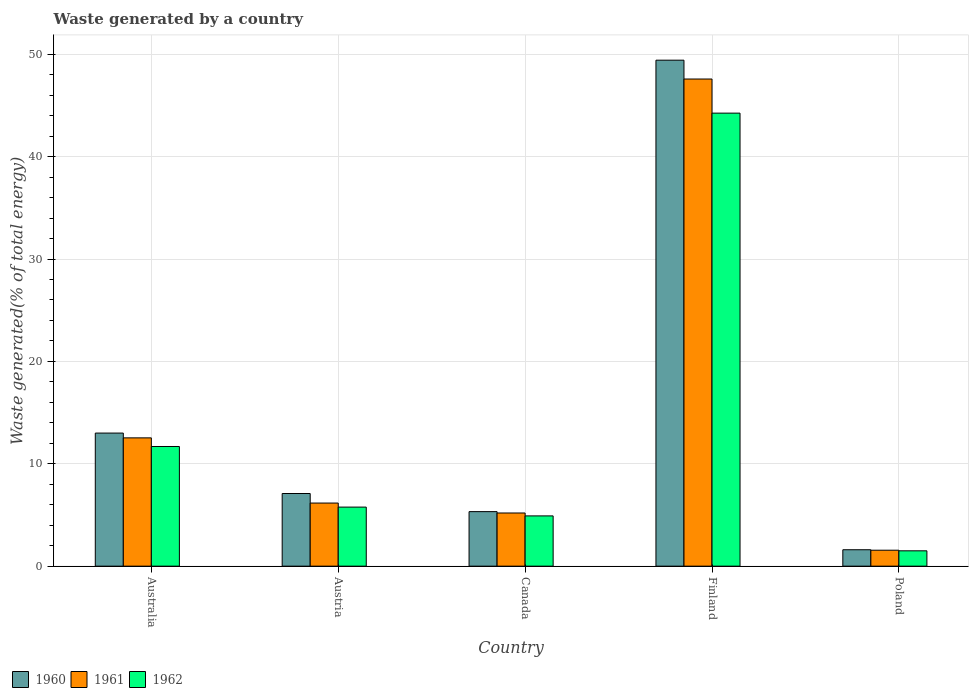How many different coloured bars are there?
Your response must be concise. 3. How many groups of bars are there?
Make the answer very short. 5. Are the number of bars per tick equal to the number of legend labels?
Provide a short and direct response. Yes. What is the label of the 3rd group of bars from the left?
Give a very brief answer. Canada. What is the total waste generated in 1961 in Australia?
Ensure brevity in your answer.  12.53. Across all countries, what is the maximum total waste generated in 1961?
Give a very brief answer. 47.58. Across all countries, what is the minimum total waste generated in 1962?
Offer a terse response. 1.5. What is the total total waste generated in 1962 in the graph?
Make the answer very short. 68.12. What is the difference between the total waste generated in 1960 in Austria and that in Poland?
Provide a succinct answer. 5.49. What is the difference between the total waste generated in 1962 in Poland and the total waste generated in 1961 in Canada?
Give a very brief answer. -3.7. What is the average total waste generated in 1962 per country?
Keep it short and to the point. 13.62. What is the difference between the total waste generated of/in 1962 and total waste generated of/in 1961 in Austria?
Keep it short and to the point. -0.4. In how many countries, is the total waste generated in 1962 greater than 12 %?
Keep it short and to the point. 1. What is the ratio of the total waste generated in 1962 in Australia to that in Poland?
Ensure brevity in your answer.  7.8. Is the total waste generated in 1961 in Canada less than that in Finland?
Make the answer very short. Yes. Is the difference between the total waste generated in 1962 in Austria and Canada greater than the difference between the total waste generated in 1961 in Austria and Canada?
Keep it short and to the point. No. What is the difference between the highest and the second highest total waste generated in 1962?
Ensure brevity in your answer.  -32.56. What is the difference between the highest and the lowest total waste generated in 1961?
Offer a terse response. 46.02. In how many countries, is the total waste generated in 1961 greater than the average total waste generated in 1961 taken over all countries?
Ensure brevity in your answer.  1. Is the sum of the total waste generated in 1960 in Finland and Poland greater than the maximum total waste generated in 1961 across all countries?
Your answer should be very brief. Yes. What does the 3rd bar from the left in Canada represents?
Give a very brief answer. 1962. What does the 2nd bar from the right in Austria represents?
Your answer should be compact. 1961. Are all the bars in the graph horizontal?
Your response must be concise. No. How many countries are there in the graph?
Give a very brief answer. 5. What is the difference between two consecutive major ticks on the Y-axis?
Offer a terse response. 10. Does the graph contain grids?
Give a very brief answer. Yes. Where does the legend appear in the graph?
Give a very brief answer. Bottom left. How are the legend labels stacked?
Offer a very short reply. Horizontal. What is the title of the graph?
Provide a short and direct response. Waste generated by a country. Does "1993" appear as one of the legend labels in the graph?
Your answer should be compact. No. What is the label or title of the X-axis?
Your answer should be compact. Country. What is the label or title of the Y-axis?
Give a very brief answer. Waste generated(% of total energy). What is the Waste generated(% of total energy) of 1960 in Australia?
Ensure brevity in your answer.  13. What is the Waste generated(% of total energy) in 1961 in Australia?
Offer a terse response. 12.53. What is the Waste generated(% of total energy) in 1962 in Australia?
Offer a terse response. 11.69. What is the Waste generated(% of total energy) of 1960 in Austria?
Your answer should be very brief. 7.1. What is the Waste generated(% of total energy) in 1961 in Austria?
Provide a succinct answer. 6.16. What is the Waste generated(% of total energy) of 1962 in Austria?
Offer a very short reply. 5.77. What is the Waste generated(% of total energy) in 1960 in Canada?
Provide a succinct answer. 5.33. What is the Waste generated(% of total energy) in 1961 in Canada?
Make the answer very short. 5.19. What is the Waste generated(% of total energy) in 1962 in Canada?
Ensure brevity in your answer.  4.91. What is the Waste generated(% of total energy) in 1960 in Finland?
Provide a short and direct response. 49.42. What is the Waste generated(% of total energy) in 1961 in Finland?
Provide a short and direct response. 47.58. What is the Waste generated(% of total energy) in 1962 in Finland?
Offer a very short reply. 44.25. What is the Waste generated(% of total energy) of 1960 in Poland?
Make the answer very short. 1.6. What is the Waste generated(% of total energy) in 1961 in Poland?
Offer a very short reply. 1.56. What is the Waste generated(% of total energy) in 1962 in Poland?
Offer a terse response. 1.5. Across all countries, what is the maximum Waste generated(% of total energy) in 1960?
Your answer should be very brief. 49.42. Across all countries, what is the maximum Waste generated(% of total energy) of 1961?
Your answer should be compact. 47.58. Across all countries, what is the maximum Waste generated(% of total energy) in 1962?
Provide a short and direct response. 44.25. Across all countries, what is the minimum Waste generated(% of total energy) in 1960?
Provide a short and direct response. 1.6. Across all countries, what is the minimum Waste generated(% of total energy) in 1961?
Provide a succinct answer. 1.56. Across all countries, what is the minimum Waste generated(% of total energy) in 1962?
Provide a succinct answer. 1.5. What is the total Waste generated(% of total energy) in 1960 in the graph?
Ensure brevity in your answer.  76.45. What is the total Waste generated(% of total energy) of 1961 in the graph?
Offer a very short reply. 73.03. What is the total Waste generated(% of total energy) in 1962 in the graph?
Keep it short and to the point. 68.12. What is the difference between the Waste generated(% of total energy) in 1960 in Australia and that in Austria?
Ensure brevity in your answer.  5.9. What is the difference between the Waste generated(% of total energy) in 1961 in Australia and that in Austria?
Your answer should be compact. 6.37. What is the difference between the Waste generated(% of total energy) of 1962 in Australia and that in Austria?
Offer a terse response. 5.92. What is the difference between the Waste generated(% of total energy) of 1960 in Australia and that in Canada?
Offer a terse response. 7.67. What is the difference between the Waste generated(% of total energy) of 1961 in Australia and that in Canada?
Your response must be concise. 7.34. What is the difference between the Waste generated(% of total energy) of 1962 in Australia and that in Canada?
Your answer should be very brief. 6.78. What is the difference between the Waste generated(% of total energy) of 1960 in Australia and that in Finland?
Keep it short and to the point. -36.42. What is the difference between the Waste generated(% of total energy) of 1961 in Australia and that in Finland?
Provide a succinct answer. -35.05. What is the difference between the Waste generated(% of total energy) in 1962 in Australia and that in Finland?
Your response must be concise. -32.56. What is the difference between the Waste generated(% of total energy) in 1960 in Australia and that in Poland?
Provide a short and direct response. 11.4. What is the difference between the Waste generated(% of total energy) of 1961 in Australia and that in Poland?
Give a very brief answer. 10.97. What is the difference between the Waste generated(% of total energy) of 1962 in Australia and that in Poland?
Make the answer very short. 10.19. What is the difference between the Waste generated(% of total energy) in 1960 in Austria and that in Canada?
Keep it short and to the point. 1.77. What is the difference between the Waste generated(% of total energy) of 1961 in Austria and that in Canada?
Keep it short and to the point. 0.97. What is the difference between the Waste generated(% of total energy) in 1962 in Austria and that in Canada?
Your response must be concise. 0.86. What is the difference between the Waste generated(% of total energy) in 1960 in Austria and that in Finland?
Your answer should be compact. -42.33. What is the difference between the Waste generated(% of total energy) in 1961 in Austria and that in Finland?
Your answer should be very brief. -41.42. What is the difference between the Waste generated(% of total energy) of 1962 in Austria and that in Finland?
Make the answer very short. -38.48. What is the difference between the Waste generated(% of total energy) of 1960 in Austria and that in Poland?
Make the answer very short. 5.49. What is the difference between the Waste generated(% of total energy) of 1961 in Austria and that in Poland?
Your answer should be very brief. 4.61. What is the difference between the Waste generated(% of total energy) in 1962 in Austria and that in Poland?
Your answer should be very brief. 4.27. What is the difference between the Waste generated(% of total energy) in 1960 in Canada and that in Finland?
Your answer should be very brief. -44.1. What is the difference between the Waste generated(% of total energy) of 1961 in Canada and that in Finland?
Ensure brevity in your answer.  -42.39. What is the difference between the Waste generated(% of total energy) of 1962 in Canada and that in Finland?
Make the answer very short. -39.34. What is the difference between the Waste generated(% of total energy) of 1960 in Canada and that in Poland?
Your response must be concise. 3.72. What is the difference between the Waste generated(% of total energy) of 1961 in Canada and that in Poland?
Offer a very short reply. 3.64. What is the difference between the Waste generated(% of total energy) of 1962 in Canada and that in Poland?
Provide a short and direct response. 3.41. What is the difference between the Waste generated(% of total energy) in 1960 in Finland and that in Poland?
Provide a short and direct response. 47.82. What is the difference between the Waste generated(% of total energy) in 1961 in Finland and that in Poland?
Your answer should be compact. 46.02. What is the difference between the Waste generated(% of total energy) of 1962 in Finland and that in Poland?
Provide a short and direct response. 42.75. What is the difference between the Waste generated(% of total energy) in 1960 in Australia and the Waste generated(% of total energy) in 1961 in Austria?
Offer a terse response. 6.84. What is the difference between the Waste generated(% of total energy) in 1960 in Australia and the Waste generated(% of total energy) in 1962 in Austria?
Ensure brevity in your answer.  7.23. What is the difference between the Waste generated(% of total energy) of 1961 in Australia and the Waste generated(% of total energy) of 1962 in Austria?
Make the answer very short. 6.76. What is the difference between the Waste generated(% of total energy) of 1960 in Australia and the Waste generated(% of total energy) of 1961 in Canada?
Provide a short and direct response. 7.81. What is the difference between the Waste generated(% of total energy) of 1960 in Australia and the Waste generated(% of total energy) of 1962 in Canada?
Make the answer very short. 8.09. What is the difference between the Waste generated(% of total energy) in 1961 in Australia and the Waste generated(% of total energy) in 1962 in Canada?
Provide a short and direct response. 7.62. What is the difference between the Waste generated(% of total energy) in 1960 in Australia and the Waste generated(% of total energy) in 1961 in Finland?
Make the answer very short. -34.58. What is the difference between the Waste generated(% of total energy) of 1960 in Australia and the Waste generated(% of total energy) of 1962 in Finland?
Your response must be concise. -31.25. What is the difference between the Waste generated(% of total energy) of 1961 in Australia and the Waste generated(% of total energy) of 1962 in Finland?
Keep it short and to the point. -31.72. What is the difference between the Waste generated(% of total energy) in 1960 in Australia and the Waste generated(% of total energy) in 1961 in Poland?
Make the answer very short. 11.44. What is the difference between the Waste generated(% of total energy) in 1960 in Australia and the Waste generated(% of total energy) in 1962 in Poland?
Make the answer very short. 11.5. What is the difference between the Waste generated(% of total energy) of 1961 in Australia and the Waste generated(% of total energy) of 1962 in Poland?
Your answer should be compact. 11.03. What is the difference between the Waste generated(% of total energy) of 1960 in Austria and the Waste generated(% of total energy) of 1961 in Canada?
Offer a very short reply. 1.9. What is the difference between the Waste generated(% of total energy) of 1960 in Austria and the Waste generated(% of total energy) of 1962 in Canada?
Offer a very short reply. 2.19. What is the difference between the Waste generated(% of total energy) in 1961 in Austria and the Waste generated(% of total energy) in 1962 in Canada?
Keep it short and to the point. 1.25. What is the difference between the Waste generated(% of total energy) in 1960 in Austria and the Waste generated(% of total energy) in 1961 in Finland?
Offer a terse response. -40.48. What is the difference between the Waste generated(% of total energy) in 1960 in Austria and the Waste generated(% of total energy) in 1962 in Finland?
Make the answer very short. -37.15. What is the difference between the Waste generated(% of total energy) of 1961 in Austria and the Waste generated(% of total energy) of 1962 in Finland?
Ensure brevity in your answer.  -38.09. What is the difference between the Waste generated(% of total energy) in 1960 in Austria and the Waste generated(% of total energy) in 1961 in Poland?
Provide a short and direct response. 5.54. What is the difference between the Waste generated(% of total energy) of 1960 in Austria and the Waste generated(% of total energy) of 1962 in Poland?
Provide a succinct answer. 5.6. What is the difference between the Waste generated(% of total energy) of 1961 in Austria and the Waste generated(% of total energy) of 1962 in Poland?
Ensure brevity in your answer.  4.67. What is the difference between the Waste generated(% of total energy) in 1960 in Canada and the Waste generated(% of total energy) in 1961 in Finland?
Provide a succinct answer. -42.25. What is the difference between the Waste generated(% of total energy) in 1960 in Canada and the Waste generated(% of total energy) in 1962 in Finland?
Your answer should be compact. -38.92. What is the difference between the Waste generated(% of total energy) of 1961 in Canada and the Waste generated(% of total energy) of 1962 in Finland?
Provide a succinct answer. -39.06. What is the difference between the Waste generated(% of total energy) of 1960 in Canada and the Waste generated(% of total energy) of 1961 in Poland?
Provide a succinct answer. 3.77. What is the difference between the Waste generated(% of total energy) of 1960 in Canada and the Waste generated(% of total energy) of 1962 in Poland?
Offer a terse response. 3.83. What is the difference between the Waste generated(% of total energy) in 1961 in Canada and the Waste generated(% of total energy) in 1962 in Poland?
Make the answer very short. 3.7. What is the difference between the Waste generated(% of total energy) in 1960 in Finland and the Waste generated(% of total energy) in 1961 in Poland?
Give a very brief answer. 47.86. What is the difference between the Waste generated(% of total energy) in 1960 in Finland and the Waste generated(% of total energy) in 1962 in Poland?
Your answer should be very brief. 47.92. What is the difference between the Waste generated(% of total energy) of 1961 in Finland and the Waste generated(% of total energy) of 1962 in Poland?
Your response must be concise. 46.08. What is the average Waste generated(% of total energy) of 1960 per country?
Keep it short and to the point. 15.29. What is the average Waste generated(% of total energy) in 1961 per country?
Provide a succinct answer. 14.61. What is the average Waste generated(% of total energy) of 1962 per country?
Ensure brevity in your answer.  13.62. What is the difference between the Waste generated(% of total energy) of 1960 and Waste generated(% of total energy) of 1961 in Australia?
Ensure brevity in your answer.  0.47. What is the difference between the Waste generated(% of total energy) of 1960 and Waste generated(% of total energy) of 1962 in Australia?
Offer a terse response. 1.31. What is the difference between the Waste generated(% of total energy) of 1961 and Waste generated(% of total energy) of 1962 in Australia?
Keep it short and to the point. 0.84. What is the difference between the Waste generated(% of total energy) of 1960 and Waste generated(% of total energy) of 1961 in Austria?
Give a very brief answer. 0.93. What is the difference between the Waste generated(% of total energy) of 1960 and Waste generated(% of total energy) of 1962 in Austria?
Your response must be concise. 1.33. What is the difference between the Waste generated(% of total energy) of 1961 and Waste generated(% of total energy) of 1962 in Austria?
Offer a terse response. 0.4. What is the difference between the Waste generated(% of total energy) in 1960 and Waste generated(% of total energy) in 1961 in Canada?
Ensure brevity in your answer.  0.13. What is the difference between the Waste generated(% of total energy) of 1960 and Waste generated(% of total energy) of 1962 in Canada?
Your answer should be very brief. 0.42. What is the difference between the Waste generated(% of total energy) of 1961 and Waste generated(% of total energy) of 1962 in Canada?
Keep it short and to the point. 0.28. What is the difference between the Waste generated(% of total energy) of 1960 and Waste generated(% of total energy) of 1961 in Finland?
Offer a very short reply. 1.84. What is the difference between the Waste generated(% of total energy) of 1960 and Waste generated(% of total energy) of 1962 in Finland?
Keep it short and to the point. 5.17. What is the difference between the Waste generated(% of total energy) of 1961 and Waste generated(% of total energy) of 1962 in Finland?
Provide a succinct answer. 3.33. What is the difference between the Waste generated(% of total energy) of 1960 and Waste generated(% of total energy) of 1961 in Poland?
Offer a very short reply. 0.05. What is the difference between the Waste generated(% of total energy) of 1960 and Waste generated(% of total energy) of 1962 in Poland?
Ensure brevity in your answer.  0.11. What is the difference between the Waste generated(% of total energy) of 1961 and Waste generated(% of total energy) of 1962 in Poland?
Your answer should be compact. 0.06. What is the ratio of the Waste generated(% of total energy) in 1960 in Australia to that in Austria?
Ensure brevity in your answer.  1.83. What is the ratio of the Waste generated(% of total energy) of 1961 in Australia to that in Austria?
Provide a succinct answer. 2.03. What is the ratio of the Waste generated(% of total energy) of 1962 in Australia to that in Austria?
Ensure brevity in your answer.  2.03. What is the ratio of the Waste generated(% of total energy) of 1960 in Australia to that in Canada?
Offer a very short reply. 2.44. What is the ratio of the Waste generated(% of total energy) of 1961 in Australia to that in Canada?
Provide a succinct answer. 2.41. What is the ratio of the Waste generated(% of total energy) in 1962 in Australia to that in Canada?
Provide a short and direct response. 2.38. What is the ratio of the Waste generated(% of total energy) of 1960 in Australia to that in Finland?
Offer a terse response. 0.26. What is the ratio of the Waste generated(% of total energy) of 1961 in Australia to that in Finland?
Provide a short and direct response. 0.26. What is the ratio of the Waste generated(% of total energy) in 1962 in Australia to that in Finland?
Your answer should be very brief. 0.26. What is the ratio of the Waste generated(% of total energy) of 1960 in Australia to that in Poland?
Give a very brief answer. 8.1. What is the ratio of the Waste generated(% of total energy) of 1961 in Australia to that in Poland?
Offer a terse response. 8.04. What is the ratio of the Waste generated(% of total energy) of 1962 in Australia to that in Poland?
Give a very brief answer. 7.8. What is the ratio of the Waste generated(% of total energy) in 1960 in Austria to that in Canada?
Offer a very short reply. 1.33. What is the ratio of the Waste generated(% of total energy) of 1961 in Austria to that in Canada?
Your answer should be very brief. 1.19. What is the ratio of the Waste generated(% of total energy) of 1962 in Austria to that in Canada?
Keep it short and to the point. 1.17. What is the ratio of the Waste generated(% of total energy) of 1960 in Austria to that in Finland?
Offer a very short reply. 0.14. What is the ratio of the Waste generated(% of total energy) of 1961 in Austria to that in Finland?
Offer a terse response. 0.13. What is the ratio of the Waste generated(% of total energy) in 1962 in Austria to that in Finland?
Make the answer very short. 0.13. What is the ratio of the Waste generated(% of total energy) of 1960 in Austria to that in Poland?
Your answer should be very brief. 4.42. What is the ratio of the Waste generated(% of total energy) in 1961 in Austria to that in Poland?
Give a very brief answer. 3.96. What is the ratio of the Waste generated(% of total energy) in 1962 in Austria to that in Poland?
Give a very brief answer. 3.85. What is the ratio of the Waste generated(% of total energy) in 1960 in Canada to that in Finland?
Give a very brief answer. 0.11. What is the ratio of the Waste generated(% of total energy) of 1961 in Canada to that in Finland?
Make the answer very short. 0.11. What is the ratio of the Waste generated(% of total energy) in 1962 in Canada to that in Finland?
Ensure brevity in your answer.  0.11. What is the ratio of the Waste generated(% of total energy) of 1960 in Canada to that in Poland?
Your answer should be very brief. 3.32. What is the ratio of the Waste generated(% of total energy) in 1961 in Canada to that in Poland?
Your response must be concise. 3.33. What is the ratio of the Waste generated(% of total energy) of 1962 in Canada to that in Poland?
Your response must be concise. 3.28. What is the ratio of the Waste generated(% of total energy) of 1960 in Finland to that in Poland?
Ensure brevity in your answer.  30.8. What is the ratio of the Waste generated(% of total energy) in 1961 in Finland to that in Poland?
Your response must be concise. 30.53. What is the ratio of the Waste generated(% of total energy) in 1962 in Finland to that in Poland?
Make the answer very short. 29.52. What is the difference between the highest and the second highest Waste generated(% of total energy) in 1960?
Offer a very short reply. 36.42. What is the difference between the highest and the second highest Waste generated(% of total energy) of 1961?
Offer a very short reply. 35.05. What is the difference between the highest and the second highest Waste generated(% of total energy) of 1962?
Give a very brief answer. 32.56. What is the difference between the highest and the lowest Waste generated(% of total energy) of 1960?
Offer a very short reply. 47.82. What is the difference between the highest and the lowest Waste generated(% of total energy) of 1961?
Your response must be concise. 46.02. What is the difference between the highest and the lowest Waste generated(% of total energy) of 1962?
Ensure brevity in your answer.  42.75. 